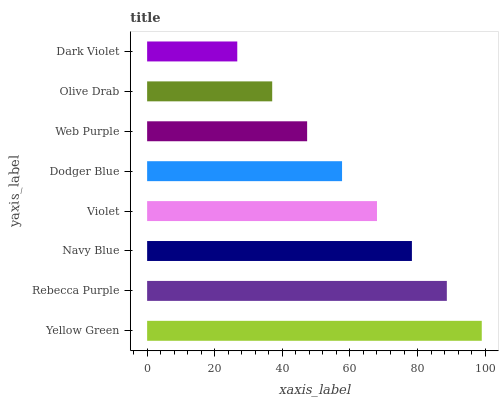Is Dark Violet the minimum?
Answer yes or no. Yes. Is Yellow Green the maximum?
Answer yes or no. Yes. Is Rebecca Purple the minimum?
Answer yes or no. No. Is Rebecca Purple the maximum?
Answer yes or no. No. Is Yellow Green greater than Rebecca Purple?
Answer yes or no. Yes. Is Rebecca Purple less than Yellow Green?
Answer yes or no. Yes. Is Rebecca Purple greater than Yellow Green?
Answer yes or no. No. Is Yellow Green less than Rebecca Purple?
Answer yes or no. No. Is Violet the high median?
Answer yes or no. Yes. Is Dodger Blue the low median?
Answer yes or no. Yes. Is Navy Blue the high median?
Answer yes or no. No. Is Dark Violet the low median?
Answer yes or no. No. 